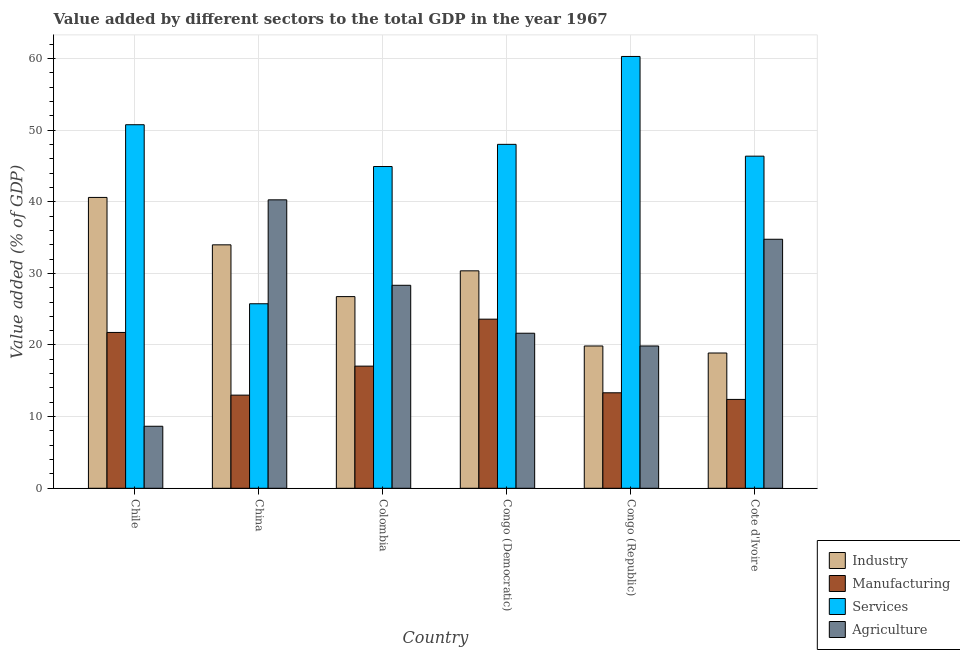How many different coloured bars are there?
Provide a short and direct response. 4. How many groups of bars are there?
Make the answer very short. 6. Are the number of bars on each tick of the X-axis equal?
Your answer should be compact. Yes. What is the label of the 4th group of bars from the left?
Your answer should be compact. Congo (Democratic). What is the value added by manufacturing sector in Cote d'Ivoire?
Provide a short and direct response. 12.4. Across all countries, what is the maximum value added by manufacturing sector?
Your answer should be compact. 23.61. Across all countries, what is the minimum value added by manufacturing sector?
Offer a very short reply. 12.4. In which country was the value added by agricultural sector maximum?
Offer a very short reply. China. In which country was the value added by services sector minimum?
Your answer should be compact. China. What is the total value added by services sector in the graph?
Keep it short and to the point. 276.06. What is the difference between the value added by industrial sector in Colombia and that in Congo (Democratic)?
Provide a succinct answer. -3.6. What is the difference between the value added by services sector in China and the value added by industrial sector in Chile?
Keep it short and to the point. -14.84. What is the average value added by manufacturing sector per country?
Your answer should be compact. 16.86. What is the difference between the value added by services sector and value added by industrial sector in Chile?
Provide a short and direct response. 10.15. In how many countries, is the value added by services sector greater than 40 %?
Make the answer very short. 5. What is the ratio of the value added by services sector in Chile to that in Congo (Democratic)?
Make the answer very short. 1.06. Is the value added by manufacturing sector in China less than that in Colombia?
Give a very brief answer. Yes. What is the difference between the highest and the second highest value added by industrial sector?
Offer a terse response. 6.62. What is the difference between the highest and the lowest value added by manufacturing sector?
Give a very brief answer. 11.2. Is the sum of the value added by agricultural sector in China and Congo (Democratic) greater than the maximum value added by services sector across all countries?
Offer a terse response. Yes. What does the 4th bar from the left in Cote d'Ivoire represents?
Offer a terse response. Agriculture. What does the 4th bar from the right in Chile represents?
Your response must be concise. Industry. How many bars are there?
Ensure brevity in your answer.  24. Are all the bars in the graph horizontal?
Give a very brief answer. No. How many countries are there in the graph?
Offer a very short reply. 6. Does the graph contain grids?
Your answer should be compact. Yes. Where does the legend appear in the graph?
Make the answer very short. Bottom right. How are the legend labels stacked?
Your answer should be compact. Vertical. What is the title of the graph?
Your response must be concise. Value added by different sectors to the total GDP in the year 1967. Does "UNTA" appear as one of the legend labels in the graph?
Your answer should be compact. No. What is the label or title of the Y-axis?
Offer a terse response. Value added (% of GDP). What is the Value added (% of GDP) of Industry in Chile?
Give a very brief answer. 40.6. What is the Value added (% of GDP) in Manufacturing in Chile?
Your response must be concise. 21.75. What is the Value added (% of GDP) in Services in Chile?
Provide a short and direct response. 50.75. What is the Value added (% of GDP) of Agriculture in Chile?
Ensure brevity in your answer.  8.66. What is the Value added (% of GDP) in Industry in China?
Your answer should be compact. 33.98. What is the Value added (% of GDP) in Manufacturing in China?
Your answer should be very brief. 13. What is the Value added (% of GDP) of Services in China?
Give a very brief answer. 25.76. What is the Value added (% of GDP) in Agriculture in China?
Offer a terse response. 40.26. What is the Value added (% of GDP) of Industry in Colombia?
Offer a terse response. 26.75. What is the Value added (% of GDP) of Manufacturing in Colombia?
Make the answer very short. 17.05. What is the Value added (% of GDP) of Services in Colombia?
Offer a terse response. 44.91. What is the Value added (% of GDP) of Agriculture in Colombia?
Provide a short and direct response. 28.33. What is the Value added (% of GDP) in Industry in Congo (Democratic)?
Make the answer very short. 30.35. What is the Value added (% of GDP) of Manufacturing in Congo (Democratic)?
Offer a very short reply. 23.61. What is the Value added (% of GDP) in Services in Congo (Democratic)?
Your answer should be compact. 48.01. What is the Value added (% of GDP) in Agriculture in Congo (Democratic)?
Your answer should be compact. 21.64. What is the Value added (% of GDP) of Industry in Congo (Republic)?
Your response must be concise. 19.86. What is the Value added (% of GDP) in Manufacturing in Congo (Republic)?
Your response must be concise. 13.33. What is the Value added (% of GDP) of Services in Congo (Republic)?
Give a very brief answer. 60.27. What is the Value added (% of GDP) in Agriculture in Congo (Republic)?
Offer a terse response. 19.86. What is the Value added (% of GDP) of Industry in Cote d'Ivoire?
Your answer should be very brief. 18.88. What is the Value added (% of GDP) in Manufacturing in Cote d'Ivoire?
Your response must be concise. 12.4. What is the Value added (% of GDP) in Services in Cote d'Ivoire?
Your answer should be very brief. 46.36. What is the Value added (% of GDP) in Agriculture in Cote d'Ivoire?
Make the answer very short. 34.76. Across all countries, what is the maximum Value added (% of GDP) in Industry?
Your answer should be compact. 40.6. Across all countries, what is the maximum Value added (% of GDP) of Manufacturing?
Offer a very short reply. 23.61. Across all countries, what is the maximum Value added (% of GDP) of Services?
Ensure brevity in your answer.  60.27. Across all countries, what is the maximum Value added (% of GDP) in Agriculture?
Give a very brief answer. 40.26. Across all countries, what is the minimum Value added (% of GDP) in Industry?
Your answer should be compact. 18.88. Across all countries, what is the minimum Value added (% of GDP) of Manufacturing?
Provide a short and direct response. 12.4. Across all countries, what is the minimum Value added (% of GDP) of Services?
Keep it short and to the point. 25.76. Across all countries, what is the minimum Value added (% of GDP) in Agriculture?
Offer a very short reply. 8.66. What is the total Value added (% of GDP) of Industry in the graph?
Offer a very short reply. 170.43. What is the total Value added (% of GDP) of Manufacturing in the graph?
Provide a succinct answer. 101.14. What is the total Value added (% of GDP) in Services in the graph?
Your answer should be very brief. 276.06. What is the total Value added (% of GDP) in Agriculture in the graph?
Your answer should be compact. 153.52. What is the difference between the Value added (% of GDP) of Industry in Chile and that in China?
Ensure brevity in your answer.  6.62. What is the difference between the Value added (% of GDP) of Manufacturing in Chile and that in China?
Ensure brevity in your answer.  8.75. What is the difference between the Value added (% of GDP) of Services in Chile and that in China?
Make the answer very short. 24.99. What is the difference between the Value added (% of GDP) in Agriculture in Chile and that in China?
Ensure brevity in your answer.  -31.6. What is the difference between the Value added (% of GDP) in Industry in Chile and that in Colombia?
Provide a short and direct response. 13.84. What is the difference between the Value added (% of GDP) in Manufacturing in Chile and that in Colombia?
Offer a very short reply. 4.7. What is the difference between the Value added (% of GDP) in Services in Chile and that in Colombia?
Give a very brief answer. 5.83. What is the difference between the Value added (% of GDP) in Agriculture in Chile and that in Colombia?
Make the answer very short. -19.68. What is the difference between the Value added (% of GDP) of Industry in Chile and that in Congo (Democratic)?
Your response must be concise. 10.25. What is the difference between the Value added (% of GDP) of Manufacturing in Chile and that in Congo (Democratic)?
Offer a terse response. -1.86. What is the difference between the Value added (% of GDP) in Services in Chile and that in Congo (Democratic)?
Your answer should be very brief. 2.74. What is the difference between the Value added (% of GDP) of Agriculture in Chile and that in Congo (Democratic)?
Make the answer very short. -12.99. What is the difference between the Value added (% of GDP) in Industry in Chile and that in Congo (Republic)?
Your response must be concise. 20.73. What is the difference between the Value added (% of GDP) in Manufacturing in Chile and that in Congo (Republic)?
Give a very brief answer. 8.42. What is the difference between the Value added (% of GDP) in Services in Chile and that in Congo (Republic)?
Give a very brief answer. -9.53. What is the difference between the Value added (% of GDP) in Agriculture in Chile and that in Congo (Republic)?
Make the answer very short. -11.21. What is the difference between the Value added (% of GDP) in Industry in Chile and that in Cote d'Ivoire?
Give a very brief answer. 21.72. What is the difference between the Value added (% of GDP) of Manufacturing in Chile and that in Cote d'Ivoire?
Offer a terse response. 9.35. What is the difference between the Value added (% of GDP) of Services in Chile and that in Cote d'Ivoire?
Ensure brevity in your answer.  4.39. What is the difference between the Value added (% of GDP) in Agriculture in Chile and that in Cote d'Ivoire?
Provide a succinct answer. -26.1. What is the difference between the Value added (% of GDP) in Industry in China and that in Colombia?
Ensure brevity in your answer.  7.23. What is the difference between the Value added (% of GDP) of Manufacturing in China and that in Colombia?
Your answer should be compact. -4.05. What is the difference between the Value added (% of GDP) of Services in China and that in Colombia?
Ensure brevity in your answer.  -19.16. What is the difference between the Value added (% of GDP) in Agriculture in China and that in Colombia?
Your response must be concise. 11.93. What is the difference between the Value added (% of GDP) of Industry in China and that in Congo (Democratic)?
Offer a terse response. 3.63. What is the difference between the Value added (% of GDP) of Manufacturing in China and that in Congo (Democratic)?
Provide a short and direct response. -10.61. What is the difference between the Value added (% of GDP) of Services in China and that in Congo (Democratic)?
Offer a terse response. -22.25. What is the difference between the Value added (% of GDP) of Agriculture in China and that in Congo (Democratic)?
Offer a very short reply. 18.62. What is the difference between the Value added (% of GDP) in Industry in China and that in Congo (Republic)?
Give a very brief answer. 14.12. What is the difference between the Value added (% of GDP) of Manufacturing in China and that in Congo (Republic)?
Offer a terse response. -0.33. What is the difference between the Value added (% of GDP) of Services in China and that in Congo (Republic)?
Provide a succinct answer. -34.52. What is the difference between the Value added (% of GDP) of Agriculture in China and that in Congo (Republic)?
Offer a very short reply. 20.4. What is the difference between the Value added (% of GDP) in Industry in China and that in Cote d'Ivoire?
Ensure brevity in your answer.  15.1. What is the difference between the Value added (% of GDP) of Manufacturing in China and that in Cote d'Ivoire?
Your answer should be compact. 0.6. What is the difference between the Value added (% of GDP) of Services in China and that in Cote d'Ivoire?
Give a very brief answer. -20.6. What is the difference between the Value added (% of GDP) of Agriculture in China and that in Cote d'Ivoire?
Your answer should be very brief. 5.5. What is the difference between the Value added (% of GDP) of Industry in Colombia and that in Congo (Democratic)?
Your response must be concise. -3.6. What is the difference between the Value added (% of GDP) in Manufacturing in Colombia and that in Congo (Democratic)?
Offer a very short reply. -6.56. What is the difference between the Value added (% of GDP) of Services in Colombia and that in Congo (Democratic)?
Offer a terse response. -3.1. What is the difference between the Value added (% of GDP) of Agriculture in Colombia and that in Congo (Democratic)?
Keep it short and to the point. 6.69. What is the difference between the Value added (% of GDP) in Industry in Colombia and that in Congo (Republic)?
Offer a terse response. 6.89. What is the difference between the Value added (% of GDP) of Manufacturing in Colombia and that in Congo (Republic)?
Keep it short and to the point. 3.72. What is the difference between the Value added (% of GDP) of Services in Colombia and that in Congo (Republic)?
Your answer should be very brief. -15.36. What is the difference between the Value added (% of GDP) in Agriculture in Colombia and that in Congo (Republic)?
Your response must be concise. 8.47. What is the difference between the Value added (% of GDP) of Industry in Colombia and that in Cote d'Ivoire?
Provide a succinct answer. 7.87. What is the difference between the Value added (% of GDP) in Manufacturing in Colombia and that in Cote d'Ivoire?
Give a very brief answer. 4.65. What is the difference between the Value added (% of GDP) in Services in Colombia and that in Cote d'Ivoire?
Your response must be concise. -1.45. What is the difference between the Value added (% of GDP) of Agriculture in Colombia and that in Cote d'Ivoire?
Your response must be concise. -6.43. What is the difference between the Value added (% of GDP) in Industry in Congo (Democratic) and that in Congo (Republic)?
Provide a succinct answer. 10.49. What is the difference between the Value added (% of GDP) of Manufacturing in Congo (Democratic) and that in Congo (Republic)?
Your response must be concise. 10.28. What is the difference between the Value added (% of GDP) in Services in Congo (Democratic) and that in Congo (Republic)?
Offer a terse response. -12.27. What is the difference between the Value added (% of GDP) of Agriculture in Congo (Democratic) and that in Congo (Republic)?
Ensure brevity in your answer.  1.78. What is the difference between the Value added (% of GDP) of Industry in Congo (Democratic) and that in Cote d'Ivoire?
Your answer should be compact. 11.47. What is the difference between the Value added (% of GDP) in Manufacturing in Congo (Democratic) and that in Cote d'Ivoire?
Make the answer very short. 11.2. What is the difference between the Value added (% of GDP) in Services in Congo (Democratic) and that in Cote d'Ivoire?
Keep it short and to the point. 1.65. What is the difference between the Value added (% of GDP) of Agriculture in Congo (Democratic) and that in Cote d'Ivoire?
Keep it short and to the point. -13.12. What is the difference between the Value added (% of GDP) in Industry in Congo (Republic) and that in Cote d'Ivoire?
Give a very brief answer. 0.98. What is the difference between the Value added (% of GDP) of Manufacturing in Congo (Republic) and that in Cote d'Ivoire?
Your answer should be very brief. 0.93. What is the difference between the Value added (% of GDP) of Services in Congo (Republic) and that in Cote d'Ivoire?
Your answer should be compact. 13.92. What is the difference between the Value added (% of GDP) in Agriculture in Congo (Republic) and that in Cote d'Ivoire?
Ensure brevity in your answer.  -14.9. What is the difference between the Value added (% of GDP) of Industry in Chile and the Value added (% of GDP) of Manufacturing in China?
Offer a terse response. 27.6. What is the difference between the Value added (% of GDP) of Industry in Chile and the Value added (% of GDP) of Services in China?
Your response must be concise. 14.84. What is the difference between the Value added (% of GDP) of Industry in Chile and the Value added (% of GDP) of Agriculture in China?
Your answer should be compact. 0.34. What is the difference between the Value added (% of GDP) of Manufacturing in Chile and the Value added (% of GDP) of Services in China?
Provide a short and direct response. -4.01. What is the difference between the Value added (% of GDP) of Manufacturing in Chile and the Value added (% of GDP) of Agriculture in China?
Ensure brevity in your answer.  -18.51. What is the difference between the Value added (% of GDP) of Services in Chile and the Value added (% of GDP) of Agriculture in China?
Provide a short and direct response. 10.48. What is the difference between the Value added (% of GDP) of Industry in Chile and the Value added (% of GDP) of Manufacturing in Colombia?
Your answer should be compact. 23.55. What is the difference between the Value added (% of GDP) of Industry in Chile and the Value added (% of GDP) of Services in Colombia?
Your answer should be very brief. -4.32. What is the difference between the Value added (% of GDP) in Industry in Chile and the Value added (% of GDP) in Agriculture in Colombia?
Offer a very short reply. 12.26. What is the difference between the Value added (% of GDP) in Manufacturing in Chile and the Value added (% of GDP) in Services in Colombia?
Ensure brevity in your answer.  -23.16. What is the difference between the Value added (% of GDP) in Manufacturing in Chile and the Value added (% of GDP) in Agriculture in Colombia?
Your answer should be compact. -6.58. What is the difference between the Value added (% of GDP) of Services in Chile and the Value added (% of GDP) of Agriculture in Colombia?
Make the answer very short. 22.41. What is the difference between the Value added (% of GDP) in Industry in Chile and the Value added (% of GDP) in Manufacturing in Congo (Democratic)?
Offer a very short reply. 16.99. What is the difference between the Value added (% of GDP) in Industry in Chile and the Value added (% of GDP) in Services in Congo (Democratic)?
Offer a very short reply. -7.41. What is the difference between the Value added (% of GDP) of Industry in Chile and the Value added (% of GDP) of Agriculture in Congo (Democratic)?
Your answer should be very brief. 18.95. What is the difference between the Value added (% of GDP) of Manufacturing in Chile and the Value added (% of GDP) of Services in Congo (Democratic)?
Offer a very short reply. -26.26. What is the difference between the Value added (% of GDP) in Manufacturing in Chile and the Value added (% of GDP) in Agriculture in Congo (Democratic)?
Keep it short and to the point. 0.11. What is the difference between the Value added (% of GDP) of Services in Chile and the Value added (% of GDP) of Agriculture in Congo (Democratic)?
Offer a terse response. 29.1. What is the difference between the Value added (% of GDP) of Industry in Chile and the Value added (% of GDP) of Manufacturing in Congo (Republic)?
Your answer should be compact. 27.27. What is the difference between the Value added (% of GDP) of Industry in Chile and the Value added (% of GDP) of Services in Congo (Republic)?
Provide a succinct answer. -19.68. What is the difference between the Value added (% of GDP) of Industry in Chile and the Value added (% of GDP) of Agriculture in Congo (Republic)?
Your answer should be very brief. 20.73. What is the difference between the Value added (% of GDP) of Manufacturing in Chile and the Value added (% of GDP) of Services in Congo (Republic)?
Your response must be concise. -38.52. What is the difference between the Value added (% of GDP) in Manufacturing in Chile and the Value added (% of GDP) in Agriculture in Congo (Republic)?
Provide a succinct answer. 1.89. What is the difference between the Value added (% of GDP) in Services in Chile and the Value added (% of GDP) in Agriculture in Congo (Republic)?
Ensure brevity in your answer.  30.88. What is the difference between the Value added (% of GDP) in Industry in Chile and the Value added (% of GDP) in Manufacturing in Cote d'Ivoire?
Provide a succinct answer. 28.19. What is the difference between the Value added (% of GDP) of Industry in Chile and the Value added (% of GDP) of Services in Cote d'Ivoire?
Your response must be concise. -5.76. What is the difference between the Value added (% of GDP) of Industry in Chile and the Value added (% of GDP) of Agriculture in Cote d'Ivoire?
Offer a terse response. 5.84. What is the difference between the Value added (% of GDP) in Manufacturing in Chile and the Value added (% of GDP) in Services in Cote d'Ivoire?
Ensure brevity in your answer.  -24.61. What is the difference between the Value added (% of GDP) in Manufacturing in Chile and the Value added (% of GDP) in Agriculture in Cote d'Ivoire?
Provide a short and direct response. -13.01. What is the difference between the Value added (% of GDP) of Services in Chile and the Value added (% of GDP) of Agriculture in Cote d'Ivoire?
Ensure brevity in your answer.  15.99. What is the difference between the Value added (% of GDP) in Industry in China and the Value added (% of GDP) in Manufacturing in Colombia?
Offer a terse response. 16.93. What is the difference between the Value added (% of GDP) of Industry in China and the Value added (% of GDP) of Services in Colombia?
Make the answer very short. -10.93. What is the difference between the Value added (% of GDP) of Industry in China and the Value added (% of GDP) of Agriculture in Colombia?
Give a very brief answer. 5.65. What is the difference between the Value added (% of GDP) in Manufacturing in China and the Value added (% of GDP) in Services in Colombia?
Your response must be concise. -31.91. What is the difference between the Value added (% of GDP) of Manufacturing in China and the Value added (% of GDP) of Agriculture in Colombia?
Your response must be concise. -15.33. What is the difference between the Value added (% of GDP) of Services in China and the Value added (% of GDP) of Agriculture in Colombia?
Ensure brevity in your answer.  -2.58. What is the difference between the Value added (% of GDP) of Industry in China and the Value added (% of GDP) of Manufacturing in Congo (Democratic)?
Ensure brevity in your answer.  10.37. What is the difference between the Value added (% of GDP) of Industry in China and the Value added (% of GDP) of Services in Congo (Democratic)?
Give a very brief answer. -14.03. What is the difference between the Value added (% of GDP) in Industry in China and the Value added (% of GDP) in Agriculture in Congo (Democratic)?
Make the answer very short. 12.34. What is the difference between the Value added (% of GDP) in Manufacturing in China and the Value added (% of GDP) in Services in Congo (Democratic)?
Offer a terse response. -35.01. What is the difference between the Value added (% of GDP) of Manufacturing in China and the Value added (% of GDP) of Agriculture in Congo (Democratic)?
Provide a succinct answer. -8.64. What is the difference between the Value added (% of GDP) of Services in China and the Value added (% of GDP) of Agriculture in Congo (Democratic)?
Your response must be concise. 4.11. What is the difference between the Value added (% of GDP) in Industry in China and the Value added (% of GDP) in Manufacturing in Congo (Republic)?
Offer a terse response. 20.65. What is the difference between the Value added (% of GDP) in Industry in China and the Value added (% of GDP) in Services in Congo (Republic)?
Your answer should be very brief. -26.29. What is the difference between the Value added (% of GDP) of Industry in China and the Value added (% of GDP) of Agriculture in Congo (Republic)?
Give a very brief answer. 14.12. What is the difference between the Value added (% of GDP) in Manufacturing in China and the Value added (% of GDP) in Services in Congo (Republic)?
Your response must be concise. -47.27. What is the difference between the Value added (% of GDP) in Manufacturing in China and the Value added (% of GDP) in Agriculture in Congo (Republic)?
Offer a very short reply. -6.86. What is the difference between the Value added (% of GDP) of Services in China and the Value added (% of GDP) of Agriculture in Congo (Republic)?
Ensure brevity in your answer.  5.89. What is the difference between the Value added (% of GDP) in Industry in China and the Value added (% of GDP) in Manufacturing in Cote d'Ivoire?
Your response must be concise. 21.58. What is the difference between the Value added (% of GDP) in Industry in China and the Value added (% of GDP) in Services in Cote d'Ivoire?
Offer a very short reply. -12.38. What is the difference between the Value added (% of GDP) of Industry in China and the Value added (% of GDP) of Agriculture in Cote d'Ivoire?
Provide a succinct answer. -0.78. What is the difference between the Value added (% of GDP) in Manufacturing in China and the Value added (% of GDP) in Services in Cote d'Ivoire?
Provide a short and direct response. -33.36. What is the difference between the Value added (% of GDP) in Manufacturing in China and the Value added (% of GDP) in Agriculture in Cote d'Ivoire?
Your answer should be very brief. -21.76. What is the difference between the Value added (% of GDP) of Services in China and the Value added (% of GDP) of Agriculture in Cote d'Ivoire?
Keep it short and to the point. -9. What is the difference between the Value added (% of GDP) in Industry in Colombia and the Value added (% of GDP) in Manufacturing in Congo (Democratic)?
Offer a very short reply. 3.15. What is the difference between the Value added (% of GDP) in Industry in Colombia and the Value added (% of GDP) in Services in Congo (Democratic)?
Your answer should be very brief. -21.25. What is the difference between the Value added (% of GDP) in Industry in Colombia and the Value added (% of GDP) in Agriculture in Congo (Democratic)?
Provide a short and direct response. 5.11. What is the difference between the Value added (% of GDP) of Manufacturing in Colombia and the Value added (% of GDP) of Services in Congo (Democratic)?
Your answer should be compact. -30.96. What is the difference between the Value added (% of GDP) in Manufacturing in Colombia and the Value added (% of GDP) in Agriculture in Congo (Democratic)?
Your answer should be very brief. -4.59. What is the difference between the Value added (% of GDP) of Services in Colombia and the Value added (% of GDP) of Agriculture in Congo (Democratic)?
Keep it short and to the point. 23.27. What is the difference between the Value added (% of GDP) of Industry in Colombia and the Value added (% of GDP) of Manufacturing in Congo (Republic)?
Make the answer very short. 13.43. What is the difference between the Value added (% of GDP) in Industry in Colombia and the Value added (% of GDP) in Services in Congo (Republic)?
Offer a very short reply. -33.52. What is the difference between the Value added (% of GDP) of Industry in Colombia and the Value added (% of GDP) of Agriculture in Congo (Republic)?
Offer a very short reply. 6.89. What is the difference between the Value added (% of GDP) of Manufacturing in Colombia and the Value added (% of GDP) of Services in Congo (Republic)?
Provide a short and direct response. -43.22. What is the difference between the Value added (% of GDP) in Manufacturing in Colombia and the Value added (% of GDP) in Agriculture in Congo (Republic)?
Provide a succinct answer. -2.81. What is the difference between the Value added (% of GDP) in Services in Colombia and the Value added (% of GDP) in Agriculture in Congo (Republic)?
Your response must be concise. 25.05. What is the difference between the Value added (% of GDP) in Industry in Colombia and the Value added (% of GDP) in Manufacturing in Cote d'Ivoire?
Ensure brevity in your answer.  14.35. What is the difference between the Value added (% of GDP) of Industry in Colombia and the Value added (% of GDP) of Services in Cote d'Ivoire?
Give a very brief answer. -19.6. What is the difference between the Value added (% of GDP) of Industry in Colombia and the Value added (% of GDP) of Agriculture in Cote d'Ivoire?
Your response must be concise. -8.01. What is the difference between the Value added (% of GDP) of Manufacturing in Colombia and the Value added (% of GDP) of Services in Cote d'Ivoire?
Keep it short and to the point. -29.31. What is the difference between the Value added (% of GDP) in Manufacturing in Colombia and the Value added (% of GDP) in Agriculture in Cote d'Ivoire?
Your answer should be compact. -17.71. What is the difference between the Value added (% of GDP) of Services in Colombia and the Value added (% of GDP) of Agriculture in Cote d'Ivoire?
Provide a succinct answer. 10.15. What is the difference between the Value added (% of GDP) of Industry in Congo (Democratic) and the Value added (% of GDP) of Manufacturing in Congo (Republic)?
Your answer should be very brief. 17.02. What is the difference between the Value added (% of GDP) of Industry in Congo (Democratic) and the Value added (% of GDP) of Services in Congo (Republic)?
Your answer should be very brief. -29.92. What is the difference between the Value added (% of GDP) of Industry in Congo (Democratic) and the Value added (% of GDP) of Agriculture in Congo (Republic)?
Your answer should be very brief. 10.49. What is the difference between the Value added (% of GDP) in Manufacturing in Congo (Democratic) and the Value added (% of GDP) in Services in Congo (Republic)?
Provide a succinct answer. -36.67. What is the difference between the Value added (% of GDP) of Manufacturing in Congo (Democratic) and the Value added (% of GDP) of Agriculture in Congo (Republic)?
Provide a succinct answer. 3.74. What is the difference between the Value added (% of GDP) of Services in Congo (Democratic) and the Value added (% of GDP) of Agriculture in Congo (Republic)?
Offer a terse response. 28.14. What is the difference between the Value added (% of GDP) of Industry in Congo (Democratic) and the Value added (% of GDP) of Manufacturing in Cote d'Ivoire?
Your answer should be very brief. 17.95. What is the difference between the Value added (% of GDP) of Industry in Congo (Democratic) and the Value added (% of GDP) of Services in Cote d'Ivoire?
Offer a very short reply. -16.01. What is the difference between the Value added (% of GDP) of Industry in Congo (Democratic) and the Value added (% of GDP) of Agriculture in Cote d'Ivoire?
Offer a very short reply. -4.41. What is the difference between the Value added (% of GDP) of Manufacturing in Congo (Democratic) and the Value added (% of GDP) of Services in Cote d'Ivoire?
Give a very brief answer. -22.75. What is the difference between the Value added (% of GDP) in Manufacturing in Congo (Democratic) and the Value added (% of GDP) in Agriculture in Cote d'Ivoire?
Provide a short and direct response. -11.15. What is the difference between the Value added (% of GDP) in Services in Congo (Democratic) and the Value added (% of GDP) in Agriculture in Cote d'Ivoire?
Provide a succinct answer. 13.25. What is the difference between the Value added (% of GDP) in Industry in Congo (Republic) and the Value added (% of GDP) in Manufacturing in Cote d'Ivoire?
Your answer should be very brief. 7.46. What is the difference between the Value added (% of GDP) in Industry in Congo (Republic) and the Value added (% of GDP) in Services in Cote d'Ivoire?
Ensure brevity in your answer.  -26.5. What is the difference between the Value added (% of GDP) of Industry in Congo (Republic) and the Value added (% of GDP) of Agriculture in Cote d'Ivoire?
Make the answer very short. -14.9. What is the difference between the Value added (% of GDP) of Manufacturing in Congo (Republic) and the Value added (% of GDP) of Services in Cote d'Ivoire?
Your answer should be compact. -33.03. What is the difference between the Value added (% of GDP) in Manufacturing in Congo (Republic) and the Value added (% of GDP) in Agriculture in Cote d'Ivoire?
Offer a very short reply. -21.43. What is the difference between the Value added (% of GDP) of Services in Congo (Republic) and the Value added (% of GDP) of Agriculture in Cote d'Ivoire?
Offer a terse response. 25.51. What is the average Value added (% of GDP) in Industry per country?
Your answer should be very brief. 28.4. What is the average Value added (% of GDP) in Manufacturing per country?
Your response must be concise. 16.86. What is the average Value added (% of GDP) of Services per country?
Make the answer very short. 46.01. What is the average Value added (% of GDP) of Agriculture per country?
Keep it short and to the point. 25.59. What is the difference between the Value added (% of GDP) of Industry and Value added (% of GDP) of Manufacturing in Chile?
Keep it short and to the point. 18.85. What is the difference between the Value added (% of GDP) of Industry and Value added (% of GDP) of Services in Chile?
Give a very brief answer. -10.15. What is the difference between the Value added (% of GDP) in Industry and Value added (% of GDP) in Agriculture in Chile?
Your answer should be compact. 31.94. What is the difference between the Value added (% of GDP) of Manufacturing and Value added (% of GDP) of Services in Chile?
Provide a short and direct response. -29. What is the difference between the Value added (% of GDP) of Manufacturing and Value added (% of GDP) of Agriculture in Chile?
Offer a terse response. 13.09. What is the difference between the Value added (% of GDP) of Services and Value added (% of GDP) of Agriculture in Chile?
Provide a succinct answer. 42.09. What is the difference between the Value added (% of GDP) of Industry and Value added (% of GDP) of Manufacturing in China?
Give a very brief answer. 20.98. What is the difference between the Value added (% of GDP) of Industry and Value added (% of GDP) of Services in China?
Provide a short and direct response. 8.22. What is the difference between the Value added (% of GDP) in Industry and Value added (% of GDP) in Agriculture in China?
Provide a succinct answer. -6.28. What is the difference between the Value added (% of GDP) of Manufacturing and Value added (% of GDP) of Services in China?
Offer a very short reply. -12.76. What is the difference between the Value added (% of GDP) of Manufacturing and Value added (% of GDP) of Agriculture in China?
Your answer should be very brief. -27.26. What is the difference between the Value added (% of GDP) of Services and Value added (% of GDP) of Agriculture in China?
Ensure brevity in your answer.  -14.5. What is the difference between the Value added (% of GDP) in Industry and Value added (% of GDP) in Manufacturing in Colombia?
Your answer should be very brief. 9.7. What is the difference between the Value added (% of GDP) of Industry and Value added (% of GDP) of Services in Colombia?
Offer a very short reply. -18.16. What is the difference between the Value added (% of GDP) of Industry and Value added (% of GDP) of Agriculture in Colombia?
Provide a succinct answer. -1.58. What is the difference between the Value added (% of GDP) of Manufacturing and Value added (% of GDP) of Services in Colombia?
Keep it short and to the point. -27.86. What is the difference between the Value added (% of GDP) in Manufacturing and Value added (% of GDP) in Agriculture in Colombia?
Provide a succinct answer. -11.28. What is the difference between the Value added (% of GDP) in Services and Value added (% of GDP) in Agriculture in Colombia?
Your answer should be very brief. 16.58. What is the difference between the Value added (% of GDP) of Industry and Value added (% of GDP) of Manufacturing in Congo (Democratic)?
Make the answer very short. 6.74. What is the difference between the Value added (% of GDP) in Industry and Value added (% of GDP) in Services in Congo (Democratic)?
Your answer should be compact. -17.66. What is the difference between the Value added (% of GDP) of Industry and Value added (% of GDP) of Agriculture in Congo (Democratic)?
Give a very brief answer. 8.71. What is the difference between the Value added (% of GDP) in Manufacturing and Value added (% of GDP) in Services in Congo (Democratic)?
Your answer should be compact. -24.4. What is the difference between the Value added (% of GDP) of Manufacturing and Value added (% of GDP) of Agriculture in Congo (Democratic)?
Your answer should be very brief. 1.96. What is the difference between the Value added (% of GDP) in Services and Value added (% of GDP) in Agriculture in Congo (Democratic)?
Provide a succinct answer. 26.36. What is the difference between the Value added (% of GDP) in Industry and Value added (% of GDP) in Manufacturing in Congo (Republic)?
Your response must be concise. 6.53. What is the difference between the Value added (% of GDP) in Industry and Value added (% of GDP) in Services in Congo (Republic)?
Your answer should be compact. -40.41. What is the difference between the Value added (% of GDP) of Industry and Value added (% of GDP) of Agriculture in Congo (Republic)?
Ensure brevity in your answer.  0. What is the difference between the Value added (% of GDP) of Manufacturing and Value added (% of GDP) of Services in Congo (Republic)?
Your answer should be compact. -46.95. What is the difference between the Value added (% of GDP) of Manufacturing and Value added (% of GDP) of Agriculture in Congo (Republic)?
Give a very brief answer. -6.53. What is the difference between the Value added (% of GDP) of Services and Value added (% of GDP) of Agriculture in Congo (Republic)?
Give a very brief answer. 40.41. What is the difference between the Value added (% of GDP) in Industry and Value added (% of GDP) in Manufacturing in Cote d'Ivoire?
Provide a short and direct response. 6.48. What is the difference between the Value added (% of GDP) of Industry and Value added (% of GDP) of Services in Cote d'Ivoire?
Keep it short and to the point. -27.48. What is the difference between the Value added (% of GDP) of Industry and Value added (% of GDP) of Agriculture in Cote d'Ivoire?
Your response must be concise. -15.88. What is the difference between the Value added (% of GDP) in Manufacturing and Value added (% of GDP) in Services in Cote d'Ivoire?
Your answer should be compact. -33.96. What is the difference between the Value added (% of GDP) in Manufacturing and Value added (% of GDP) in Agriculture in Cote d'Ivoire?
Your answer should be compact. -22.36. What is the difference between the Value added (% of GDP) in Services and Value added (% of GDP) in Agriculture in Cote d'Ivoire?
Offer a terse response. 11.6. What is the ratio of the Value added (% of GDP) of Industry in Chile to that in China?
Make the answer very short. 1.19. What is the ratio of the Value added (% of GDP) in Manufacturing in Chile to that in China?
Offer a very short reply. 1.67. What is the ratio of the Value added (% of GDP) in Services in Chile to that in China?
Offer a very short reply. 1.97. What is the ratio of the Value added (% of GDP) in Agriculture in Chile to that in China?
Ensure brevity in your answer.  0.21. What is the ratio of the Value added (% of GDP) of Industry in Chile to that in Colombia?
Your response must be concise. 1.52. What is the ratio of the Value added (% of GDP) of Manufacturing in Chile to that in Colombia?
Your answer should be compact. 1.28. What is the ratio of the Value added (% of GDP) of Services in Chile to that in Colombia?
Ensure brevity in your answer.  1.13. What is the ratio of the Value added (% of GDP) of Agriculture in Chile to that in Colombia?
Make the answer very short. 0.31. What is the ratio of the Value added (% of GDP) in Industry in Chile to that in Congo (Democratic)?
Keep it short and to the point. 1.34. What is the ratio of the Value added (% of GDP) of Manufacturing in Chile to that in Congo (Democratic)?
Your answer should be compact. 0.92. What is the ratio of the Value added (% of GDP) in Services in Chile to that in Congo (Democratic)?
Provide a short and direct response. 1.06. What is the ratio of the Value added (% of GDP) in Industry in Chile to that in Congo (Republic)?
Offer a terse response. 2.04. What is the ratio of the Value added (% of GDP) of Manufacturing in Chile to that in Congo (Republic)?
Your response must be concise. 1.63. What is the ratio of the Value added (% of GDP) in Services in Chile to that in Congo (Republic)?
Your response must be concise. 0.84. What is the ratio of the Value added (% of GDP) in Agriculture in Chile to that in Congo (Republic)?
Offer a terse response. 0.44. What is the ratio of the Value added (% of GDP) in Industry in Chile to that in Cote d'Ivoire?
Give a very brief answer. 2.15. What is the ratio of the Value added (% of GDP) in Manufacturing in Chile to that in Cote d'Ivoire?
Give a very brief answer. 1.75. What is the ratio of the Value added (% of GDP) of Services in Chile to that in Cote d'Ivoire?
Your answer should be compact. 1.09. What is the ratio of the Value added (% of GDP) of Agriculture in Chile to that in Cote d'Ivoire?
Give a very brief answer. 0.25. What is the ratio of the Value added (% of GDP) in Industry in China to that in Colombia?
Provide a succinct answer. 1.27. What is the ratio of the Value added (% of GDP) of Manufacturing in China to that in Colombia?
Your answer should be very brief. 0.76. What is the ratio of the Value added (% of GDP) in Services in China to that in Colombia?
Your answer should be very brief. 0.57. What is the ratio of the Value added (% of GDP) of Agriculture in China to that in Colombia?
Keep it short and to the point. 1.42. What is the ratio of the Value added (% of GDP) of Industry in China to that in Congo (Democratic)?
Your answer should be very brief. 1.12. What is the ratio of the Value added (% of GDP) of Manufacturing in China to that in Congo (Democratic)?
Your answer should be compact. 0.55. What is the ratio of the Value added (% of GDP) in Services in China to that in Congo (Democratic)?
Make the answer very short. 0.54. What is the ratio of the Value added (% of GDP) in Agriculture in China to that in Congo (Democratic)?
Offer a very short reply. 1.86. What is the ratio of the Value added (% of GDP) in Industry in China to that in Congo (Republic)?
Ensure brevity in your answer.  1.71. What is the ratio of the Value added (% of GDP) in Manufacturing in China to that in Congo (Republic)?
Make the answer very short. 0.98. What is the ratio of the Value added (% of GDP) in Services in China to that in Congo (Republic)?
Your answer should be very brief. 0.43. What is the ratio of the Value added (% of GDP) in Agriculture in China to that in Congo (Republic)?
Offer a terse response. 2.03. What is the ratio of the Value added (% of GDP) of Industry in China to that in Cote d'Ivoire?
Provide a succinct answer. 1.8. What is the ratio of the Value added (% of GDP) in Manufacturing in China to that in Cote d'Ivoire?
Your response must be concise. 1.05. What is the ratio of the Value added (% of GDP) in Services in China to that in Cote d'Ivoire?
Ensure brevity in your answer.  0.56. What is the ratio of the Value added (% of GDP) of Agriculture in China to that in Cote d'Ivoire?
Provide a succinct answer. 1.16. What is the ratio of the Value added (% of GDP) in Industry in Colombia to that in Congo (Democratic)?
Your response must be concise. 0.88. What is the ratio of the Value added (% of GDP) of Manufacturing in Colombia to that in Congo (Democratic)?
Your answer should be very brief. 0.72. What is the ratio of the Value added (% of GDP) in Services in Colombia to that in Congo (Democratic)?
Your response must be concise. 0.94. What is the ratio of the Value added (% of GDP) in Agriculture in Colombia to that in Congo (Democratic)?
Offer a terse response. 1.31. What is the ratio of the Value added (% of GDP) of Industry in Colombia to that in Congo (Republic)?
Provide a short and direct response. 1.35. What is the ratio of the Value added (% of GDP) of Manufacturing in Colombia to that in Congo (Republic)?
Offer a very short reply. 1.28. What is the ratio of the Value added (% of GDP) in Services in Colombia to that in Congo (Republic)?
Your response must be concise. 0.75. What is the ratio of the Value added (% of GDP) of Agriculture in Colombia to that in Congo (Republic)?
Offer a terse response. 1.43. What is the ratio of the Value added (% of GDP) of Industry in Colombia to that in Cote d'Ivoire?
Your response must be concise. 1.42. What is the ratio of the Value added (% of GDP) in Manufacturing in Colombia to that in Cote d'Ivoire?
Give a very brief answer. 1.37. What is the ratio of the Value added (% of GDP) of Services in Colombia to that in Cote d'Ivoire?
Your response must be concise. 0.97. What is the ratio of the Value added (% of GDP) in Agriculture in Colombia to that in Cote d'Ivoire?
Offer a terse response. 0.82. What is the ratio of the Value added (% of GDP) in Industry in Congo (Democratic) to that in Congo (Republic)?
Ensure brevity in your answer.  1.53. What is the ratio of the Value added (% of GDP) of Manufacturing in Congo (Democratic) to that in Congo (Republic)?
Your response must be concise. 1.77. What is the ratio of the Value added (% of GDP) of Services in Congo (Democratic) to that in Congo (Republic)?
Offer a very short reply. 0.8. What is the ratio of the Value added (% of GDP) in Agriculture in Congo (Democratic) to that in Congo (Republic)?
Offer a terse response. 1.09. What is the ratio of the Value added (% of GDP) of Industry in Congo (Democratic) to that in Cote d'Ivoire?
Your answer should be very brief. 1.61. What is the ratio of the Value added (% of GDP) of Manufacturing in Congo (Democratic) to that in Cote d'Ivoire?
Give a very brief answer. 1.9. What is the ratio of the Value added (% of GDP) of Services in Congo (Democratic) to that in Cote d'Ivoire?
Offer a terse response. 1.04. What is the ratio of the Value added (% of GDP) in Agriculture in Congo (Democratic) to that in Cote d'Ivoire?
Make the answer very short. 0.62. What is the ratio of the Value added (% of GDP) in Industry in Congo (Republic) to that in Cote d'Ivoire?
Your answer should be very brief. 1.05. What is the ratio of the Value added (% of GDP) of Manufacturing in Congo (Republic) to that in Cote d'Ivoire?
Your response must be concise. 1.07. What is the ratio of the Value added (% of GDP) of Services in Congo (Republic) to that in Cote d'Ivoire?
Your answer should be very brief. 1.3. What is the ratio of the Value added (% of GDP) in Agriculture in Congo (Republic) to that in Cote d'Ivoire?
Keep it short and to the point. 0.57. What is the difference between the highest and the second highest Value added (% of GDP) of Industry?
Your answer should be very brief. 6.62. What is the difference between the highest and the second highest Value added (% of GDP) in Manufacturing?
Ensure brevity in your answer.  1.86. What is the difference between the highest and the second highest Value added (% of GDP) in Services?
Offer a terse response. 9.53. What is the difference between the highest and the second highest Value added (% of GDP) in Agriculture?
Offer a very short reply. 5.5. What is the difference between the highest and the lowest Value added (% of GDP) in Industry?
Your answer should be compact. 21.72. What is the difference between the highest and the lowest Value added (% of GDP) in Manufacturing?
Offer a terse response. 11.2. What is the difference between the highest and the lowest Value added (% of GDP) of Services?
Ensure brevity in your answer.  34.52. What is the difference between the highest and the lowest Value added (% of GDP) of Agriculture?
Provide a short and direct response. 31.6. 